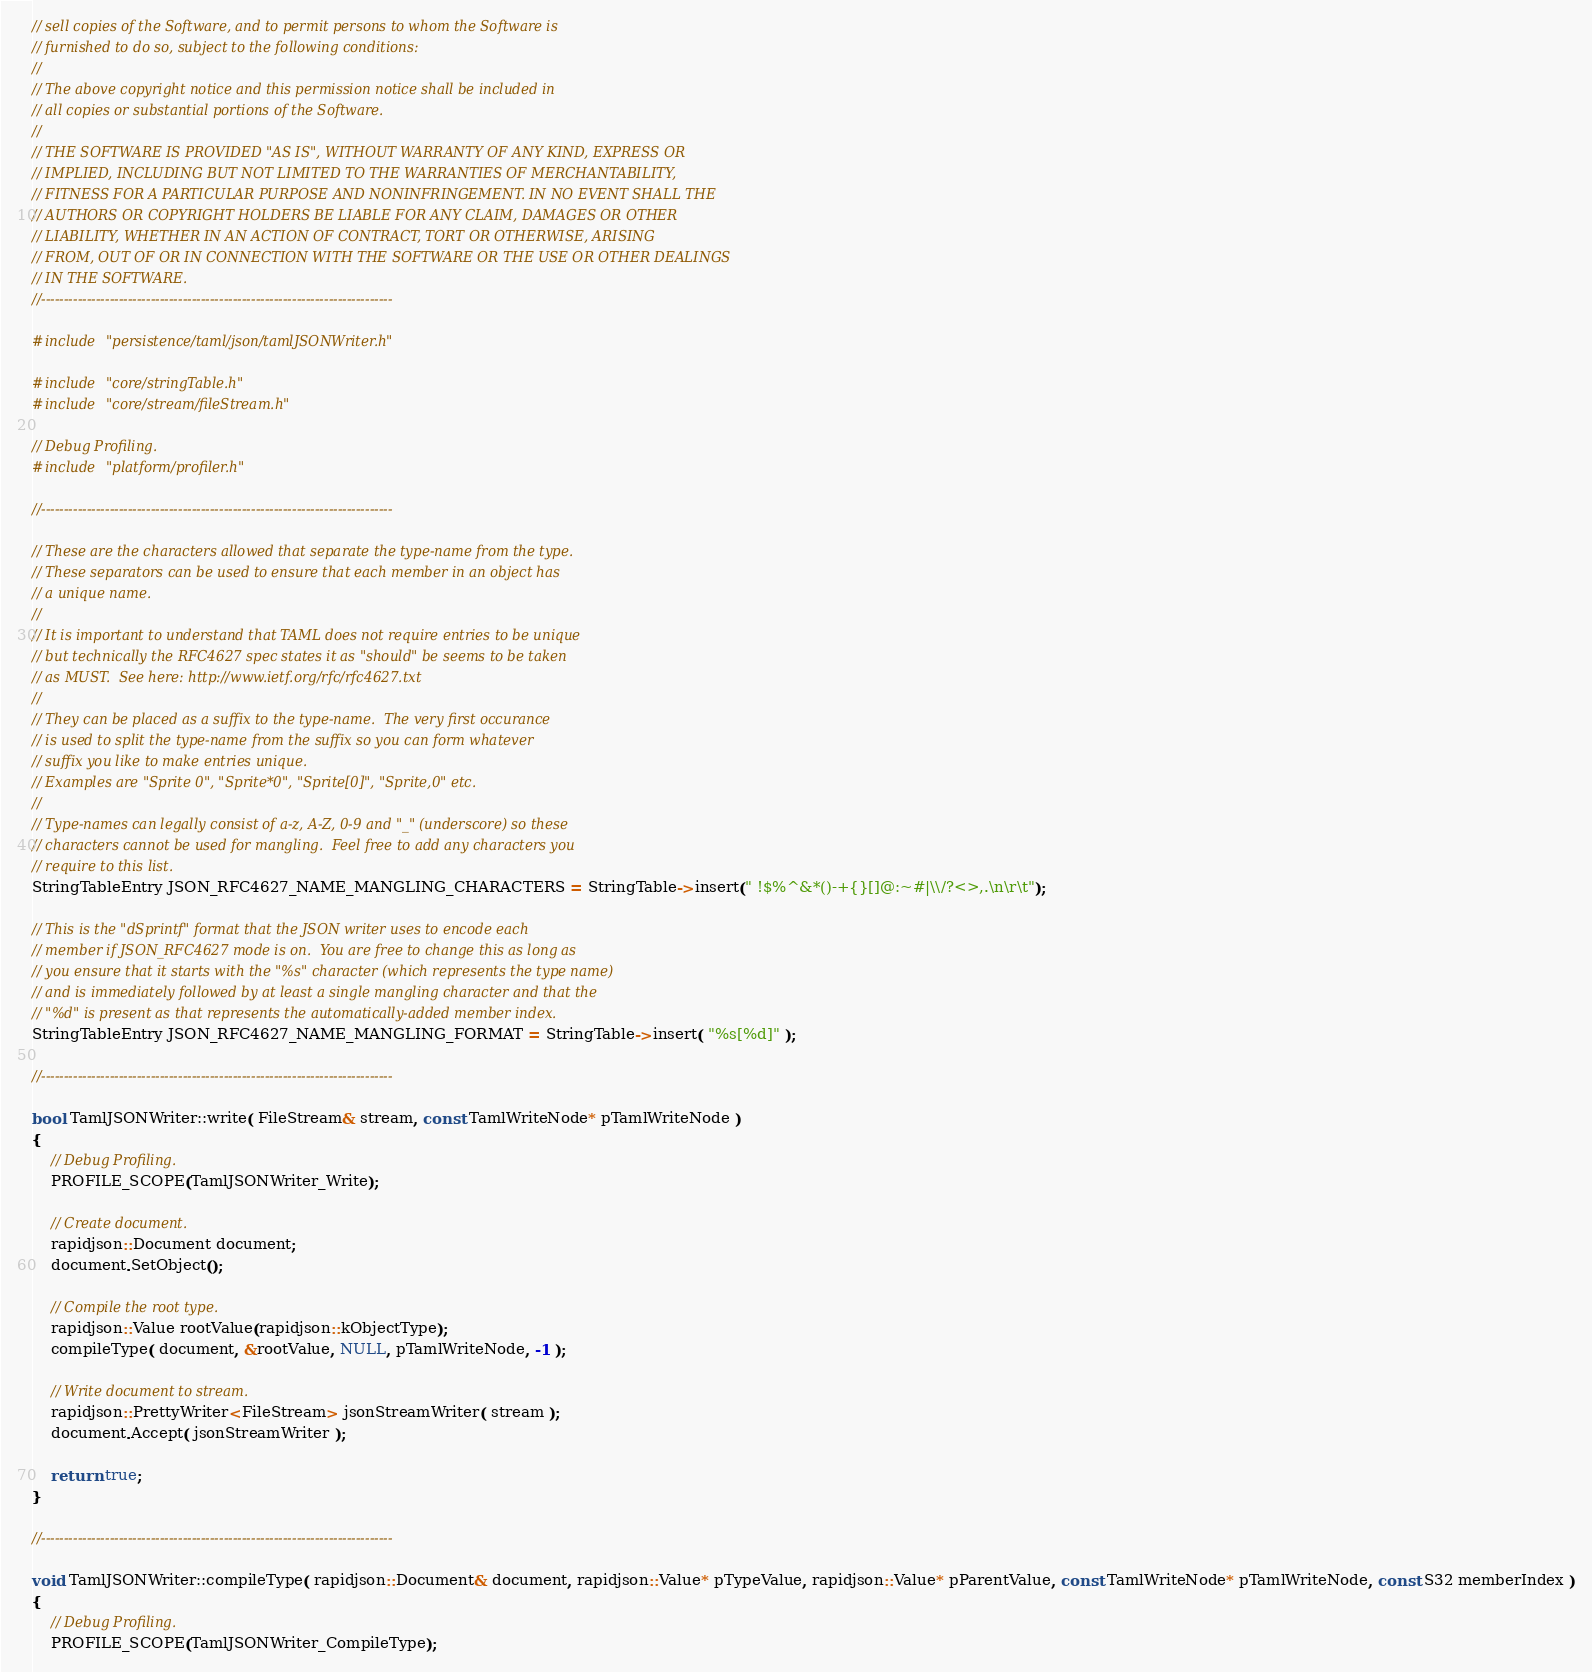<code> <loc_0><loc_0><loc_500><loc_500><_C++_>// sell copies of the Software, and to permit persons to whom the Software is
// furnished to do so, subject to the following conditions:
//
// The above copyright notice and this permission notice shall be included in
// all copies or substantial portions of the Software.
//
// THE SOFTWARE IS PROVIDED "AS IS", WITHOUT WARRANTY OF ANY KIND, EXPRESS OR
// IMPLIED, INCLUDING BUT NOT LIMITED TO THE WARRANTIES OF MERCHANTABILITY,
// FITNESS FOR A PARTICULAR PURPOSE AND NONINFRINGEMENT. IN NO EVENT SHALL THE
// AUTHORS OR COPYRIGHT HOLDERS BE LIABLE FOR ANY CLAIM, DAMAGES OR OTHER
// LIABILITY, WHETHER IN AN ACTION OF CONTRACT, TORT OR OTHERWISE, ARISING
// FROM, OUT OF OR IN CONNECTION WITH THE SOFTWARE OR THE USE OR OTHER DEALINGS
// IN THE SOFTWARE.
//-----------------------------------------------------------------------------

#include "persistence/taml/json/tamlJSONWriter.h"

#include "core/stringTable.h"
#include "core/stream/fileStream.h"

// Debug Profiling.
#include "platform/profiler.h"

//-----------------------------------------------------------------------------

// These are the characters allowed that separate the type-name from the type.
// These separators can be used to ensure that each member in an object has
// a unique name.
//
// It is important to understand that TAML does not require entries to be unique
// but technically the RFC4627 spec states it as "should" be seems to be taken
// as MUST.  See here: http://www.ietf.org/rfc/rfc4627.txt
//
// They can be placed as a suffix to the type-name.  The very first occurance
// is used to split the type-name from the suffix so you can form whatever
// suffix you like to make entries unique.
// Examples are "Sprite 0", "Sprite*0", "Sprite[0]", "Sprite,0" etc.
//
// Type-names can legally consist of a-z, A-Z, 0-9 and "_" (underscore) so these
// characters cannot be used for mangling.  Feel free to add any characters you
// require to this list.
StringTableEntry JSON_RFC4627_NAME_MANGLING_CHARACTERS = StringTable->insert(" !$%^&*()-+{}[]@:~#|\\/?<>,.\n\r\t");

// This is the "dSprintf" format that the JSON writer uses to encode each
// member if JSON_RFC4627 mode is on.  You are free to change this as long as
// you ensure that it starts with the "%s" character (which represents the type name)
// and is immediately followed by at least a single mangling character and that the
// "%d" is present as that represents the automatically-added member index.
StringTableEntry JSON_RFC4627_NAME_MANGLING_FORMAT = StringTable->insert( "%s[%d]" );

//-----------------------------------------------------------------------------

bool TamlJSONWriter::write( FileStream& stream, const TamlWriteNode* pTamlWriteNode )
{
    // Debug Profiling.
    PROFILE_SCOPE(TamlJSONWriter_Write);

    // Create document.
    rapidjson::Document document;
    document.SetObject();

    // Compile the root type.
    rapidjson::Value rootValue(rapidjson::kObjectType);
    compileType( document, &rootValue, NULL, pTamlWriteNode, -1 );

    // Write document to stream.
    rapidjson::PrettyWriter<FileStream> jsonStreamWriter( stream );
    document.Accept( jsonStreamWriter );

    return true;
}

//-----------------------------------------------------------------------------

void TamlJSONWriter::compileType( rapidjson::Document& document, rapidjson::Value* pTypeValue, rapidjson::Value* pParentValue, const TamlWriteNode* pTamlWriteNode, const S32 memberIndex )
{
    // Debug Profiling.
    PROFILE_SCOPE(TamlJSONWriter_CompileType);
</code> 